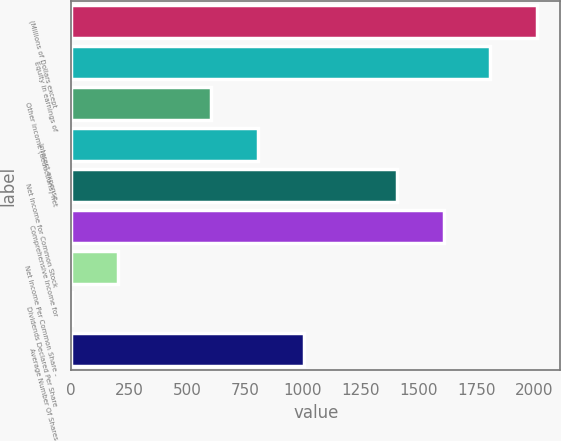Convert chart to OTSL. <chart><loc_0><loc_0><loc_500><loc_500><bar_chart><fcel>(Millions of Dollars except<fcel>Equity in earnings of<fcel>Other income (deductions) net<fcel>Interest expense<fcel>Net Income for Common Stock<fcel>Comprehensive Income for<fcel>Net Income Per Common Share -<fcel>Dividends Declared Per Share<fcel>Average Number Of Shares<nl><fcel>2012.02<fcel>1811.06<fcel>605.3<fcel>806.26<fcel>1409.14<fcel>1610.1<fcel>203.38<fcel>2.42<fcel>1007.22<nl></chart> 